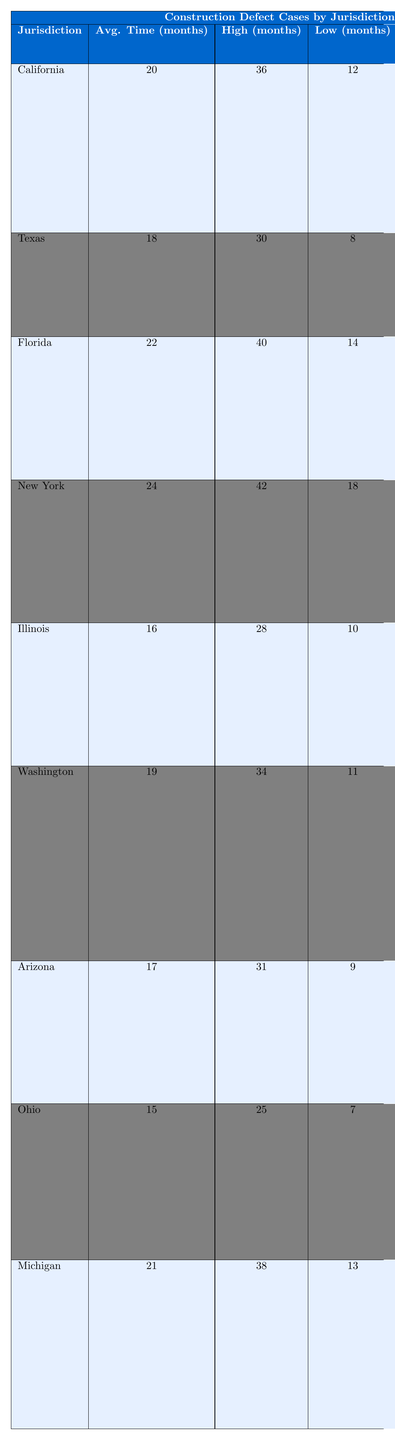What is the average time to resolution for cases in California? The table indicates that the average time to resolution for California is listed directly under the "Avg. Time (months)" column, which shows 20 months.
Answer: 20 months Which jurisdiction has the highest average time to resolution? By reviewing the "Avg. Time (months)" column, New York has the highest value at 24 months, making it the jurisdiction with the longest average time to resolution.
Answer: New York What is the settlement rate for Arizona? The settlement rate for Arizona is found in the last column of the table, which shows a rate of 72%.
Answer: 72% What are the common defects listed for Texas? The common defects for Texas, as noted in the "Common Defects" column, include Roofing issues, Plumbing leaks, and Mold growth.
Answer: Roofing issues, Plumbing leaks, Mold growth Which jurisdiction has both a high-end resolution time of 42 months and a settlement rate below 60%? The only jurisdiction that meets these criteria in the table is New York, which has a high-end resolution time of 42 months and a settlement rate of 55%.
Answer: New York What is the average time to resolution for the jurisdictions that have a settlement rate above 65%? The jurisdictions with a settlement rate above 65% are Texas (70%), Arizona (72%), and Illinois (67%). Their average time to resolution is calculated as (18 + 17 + 16) / 3 = 17 months.
Answer: 17 months Is it true that Florida has the longest low-end resolution time among the jurisdictions listed? No, Florida has a low-end resolution time of 14 months, while Ohio has a lower low-end resolution time of 7 months. Thus, Florida does not have the longest low-end resolution time.
Answer: No Calculate the difference in average time to resolution between New York and California. New York's average time is 24 months, and California's is 20 months. The difference is calculated as 24 - 20 = 4 months.
Answer: 4 months Which jurisdictions have a settlement rate of 60% or more? The jurisdictions that meet this criterion are Texas (70%), Arizona (72%), Illinois (67%), California (65%), and Michigan (64%).
Answer: Texas, Arizona, Illinois, California, Michigan What is the average high-end resolution time across all jurisdictions? Adding all the high-end resolution times (36 + 30 + 40 + 42 + 28 + 34 + 31 + 25 + 38 = 334) and dividing by the number of jurisdictions (9) gives us an average of 334 / 9 = 37.11 months.
Answer: 37.11 months What is the range of average resolution times across all jurisdictions? To find the range, we subtract the lowest average time (Ohio's 15 months) from the highest (New York's 24 months), resulting in a range of 24 - 15 = 9 months.
Answer: 9 months 